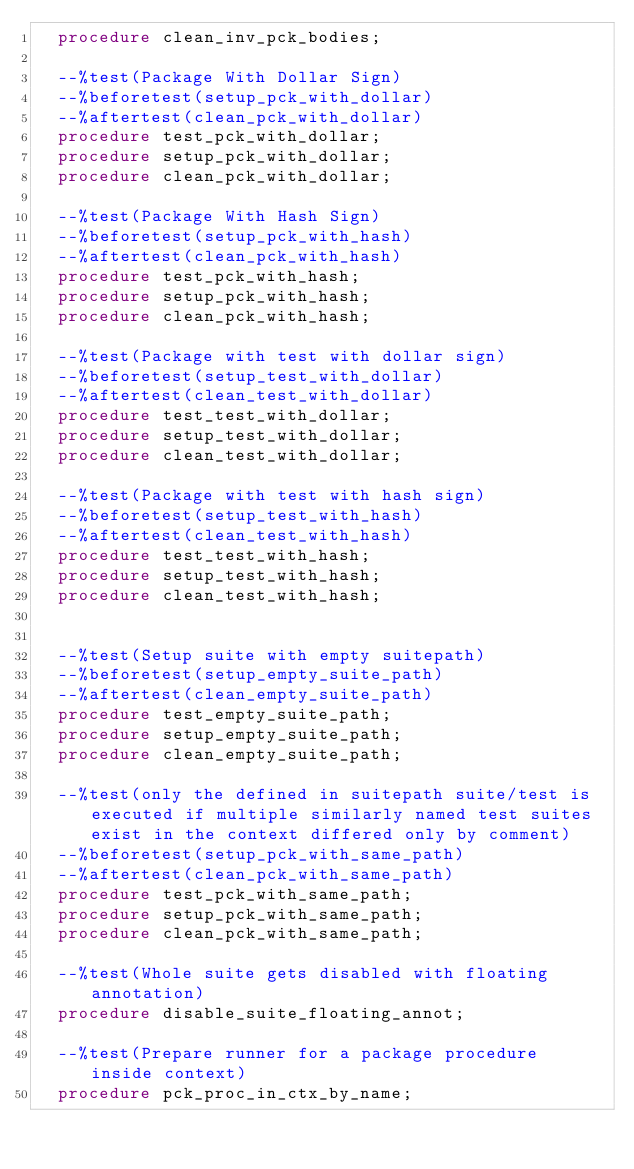<code> <loc_0><loc_0><loc_500><loc_500><_SQL_>  procedure clean_inv_pck_bodies;

  --%test(Package With Dollar Sign)
  --%beforetest(setup_pck_with_dollar)
  --%aftertest(clean_pck_with_dollar)
  procedure test_pck_with_dollar;
  procedure setup_pck_with_dollar;
  procedure clean_pck_with_dollar;

  --%test(Package With Hash Sign)
  --%beforetest(setup_pck_with_hash)
  --%aftertest(clean_pck_with_hash)
  procedure test_pck_with_hash;
  procedure setup_pck_with_hash;
  procedure clean_pck_with_hash;

  --%test(Package with test with dollar sign)
  --%beforetest(setup_test_with_dollar)
  --%aftertest(clean_test_with_dollar)
  procedure test_test_with_dollar;
  procedure setup_test_with_dollar;
  procedure clean_test_with_dollar;

  --%test(Package with test with hash sign)
  --%beforetest(setup_test_with_hash)
  --%aftertest(clean_test_with_hash)
  procedure test_test_with_hash;
  procedure setup_test_with_hash;
  procedure clean_test_with_hash;


  --%test(Setup suite with empty suitepath)
  --%beforetest(setup_empty_suite_path)
  --%aftertest(clean_empty_suite_path)
  procedure test_empty_suite_path;
  procedure setup_empty_suite_path;
  procedure clean_empty_suite_path;

  --%test(only the defined in suitepath suite/test is executed if multiple similarly named test suites exist in the context differed only by comment)
  --%beforetest(setup_pck_with_same_path)
  --%aftertest(clean_pck_with_same_path)
  procedure test_pck_with_same_path;
  procedure setup_pck_with_same_path;
  procedure clean_pck_with_same_path;

  --%test(Whole suite gets disabled with floating annotation)
  procedure disable_suite_floating_annot;

  --%test(Prepare runner for a package procedure inside context)
  procedure pck_proc_in_ctx_by_name;
</code> 